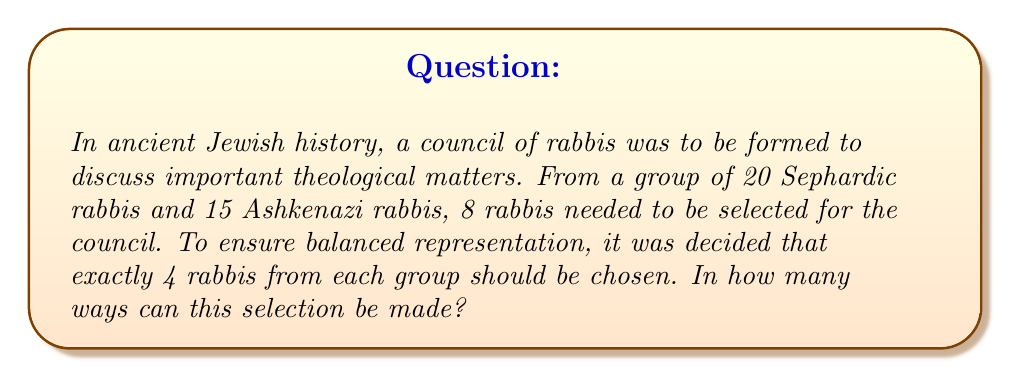What is the answer to this math problem? To solve this problem, we need to use the concept of combinations from permutations and combinations theory. Let's break it down step-by-step:

1) We need to select 4 rabbis from 20 Sephardic rabbis, and 4 rabbis from 15 Ashkenazi rabbis.

2) For the Sephardic selection:
   We're choosing 4 rabbis out of 20. This is denoted as $\binom{20}{4}$ or $C(20,4)$.
   
   $$\binom{20}{4} = \frac{20!}{4!(20-4)!} = \frac{20!}{4!16!}$$

3) For the Ashkenazi selection:
   We're choosing 4 rabbis out of 15. This is denoted as $\binom{15}{4}$ or $C(15,4)$.
   
   $$\binom{15}{4} = \frac{15!}{4!(15-4)!} = \frac{15!}{4!11!}$$

4) By the Multiplication Principle, the total number of ways to make both selections is the product of the individual selections:

   $$\text{Total Ways} = \binom{20}{4} \times \binom{15}{4}$$

5) Let's calculate each combination:

   $$\binom{20}{4} = \frac{20!}{4!16!} = 4845$$
   
   $$\binom{15}{4} = \frac{15!}{4!11!} = 1365$$

6) Now, we multiply these results:

   $$4845 \times 1365 = 6,613,425$$

Therefore, there are 6,613,425 ways to select the council.
Answer: 6,613,425 